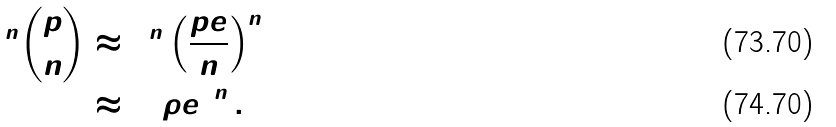Convert formula to latex. <formula><loc_0><loc_0><loc_500><loc_500>2 ^ { n } \binom { p } { n } & \approx 2 ^ { n } \left ( \frac { p e } { n } \right ) ^ { n } \\ & \approx \left ( 2 \rho e \right ) ^ { n } .</formula> 